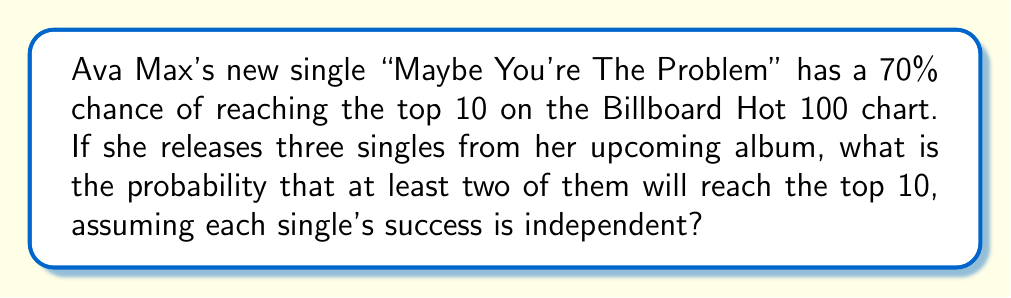Solve this math problem. Let's approach this step-by-step:

1) First, we need to recognize this as a binomial probability problem.

2) Let $p$ be the probability of success (reaching top 10) for a single, and $q$ be the probability of failure:
   $p = 0.70$
   $q = 1 - p = 0.30$

3) We want the probability of at least 2 successes out of 3 trials. This is equivalent to the probability of exactly 2 successes plus the probability of 3 successes.

4) The probability of exactly $k$ successes in $n$ trials is given by the binomial probability formula:

   $$P(X = k) = \binom{n}{k} p^k q^{n-k}$$

5) For 2 successes out of 3:
   $$P(X = 2) = \binom{3}{2} (0.70)^2 (0.30)^1 = 3 \cdot 0.49 \cdot 0.30 = 0.441$$

6) For 3 successes out of 3:
   $$P(X = 3) = \binom{3}{3} (0.70)^3 (0.30)^0 = 1 \cdot 0.343 \cdot 1 = 0.343$$

7) The probability of at least 2 successes is the sum of these probabilities:
   $$P(X \geq 2) = P(X = 2) + P(X = 3) = 0.441 + 0.343 = 0.784$$
Answer: $0.784$ or $78.4\%$ 